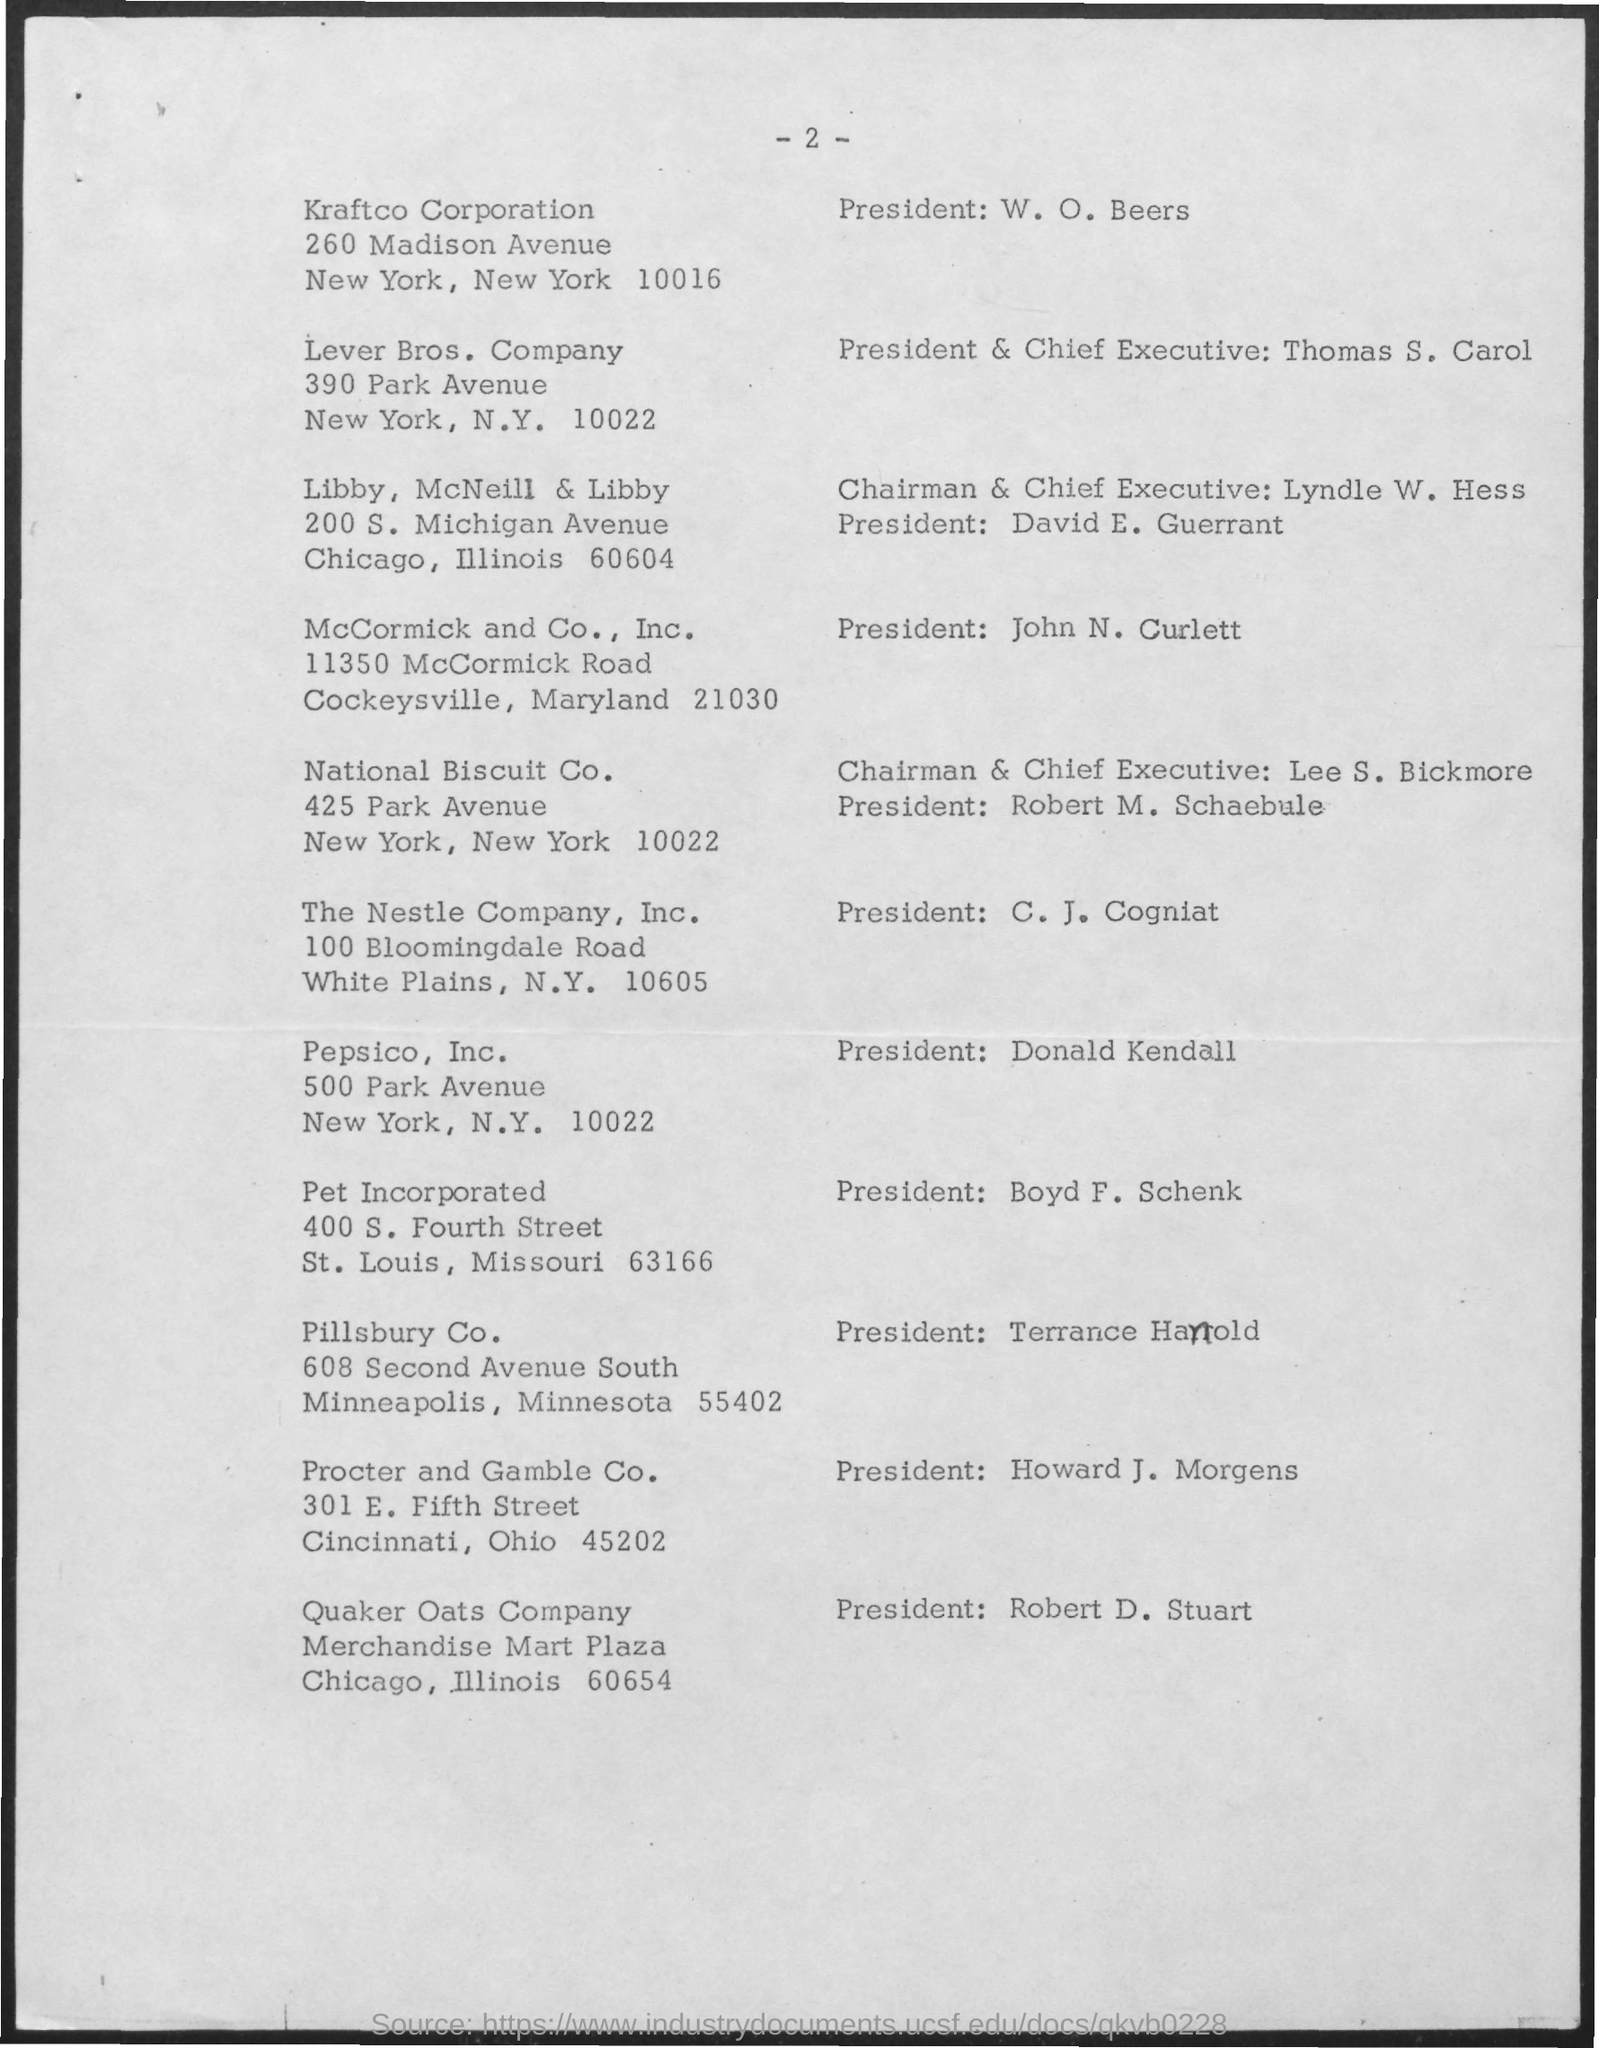Specify some key components in this picture. Howard J. Morgens is the current President of Procter and Gamble Co. Donald Kendall was the president of Pepsico, Inc. The current president and CEO of Lever Brothers company is Thomas S. Carol. The president of Kraft Co Corporation is W.O. Beers. Terrance Hanold is the president of Pillsbury Co. 